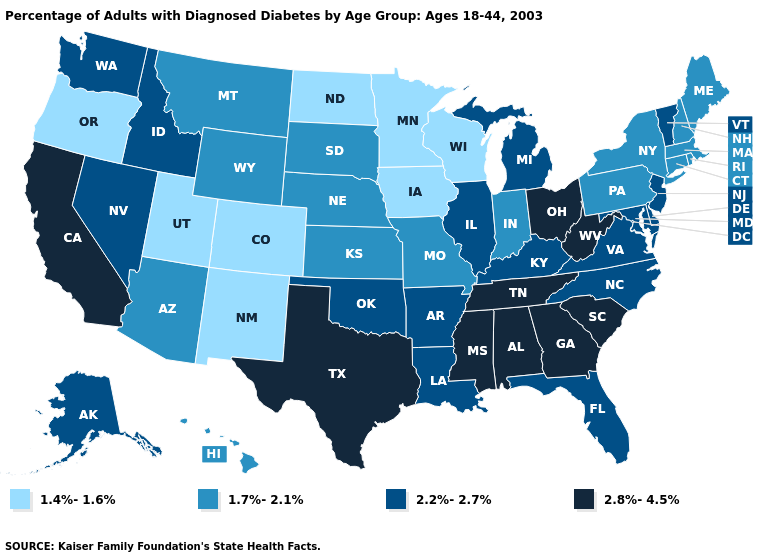What is the value of North Carolina?
Keep it brief. 2.2%-2.7%. How many symbols are there in the legend?
Keep it brief. 4. Which states have the lowest value in the USA?
Concise answer only. Colorado, Iowa, Minnesota, New Mexico, North Dakota, Oregon, Utah, Wisconsin. Does Mississippi have the highest value in the USA?
Be succinct. Yes. Is the legend a continuous bar?
Answer briefly. No. What is the value of Wisconsin?
Concise answer only. 1.4%-1.6%. Name the states that have a value in the range 2.8%-4.5%?
Concise answer only. Alabama, California, Georgia, Mississippi, Ohio, South Carolina, Tennessee, Texas, West Virginia. Name the states that have a value in the range 2.8%-4.5%?
Short answer required. Alabama, California, Georgia, Mississippi, Ohio, South Carolina, Tennessee, Texas, West Virginia. Does Montana have a higher value than Vermont?
Short answer required. No. What is the lowest value in the USA?
Short answer required. 1.4%-1.6%. What is the value of Arkansas?
Keep it brief. 2.2%-2.7%. Name the states that have a value in the range 2.2%-2.7%?
Keep it brief. Alaska, Arkansas, Delaware, Florida, Idaho, Illinois, Kentucky, Louisiana, Maryland, Michigan, Nevada, New Jersey, North Carolina, Oklahoma, Vermont, Virginia, Washington. Does Hawaii have a lower value than South Carolina?
Answer briefly. Yes. What is the lowest value in states that border South Carolina?
Short answer required. 2.2%-2.7%. Among the states that border North Carolina , which have the highest value?
Write a very short answer. Georgia, South Carolina, Tennessee. 